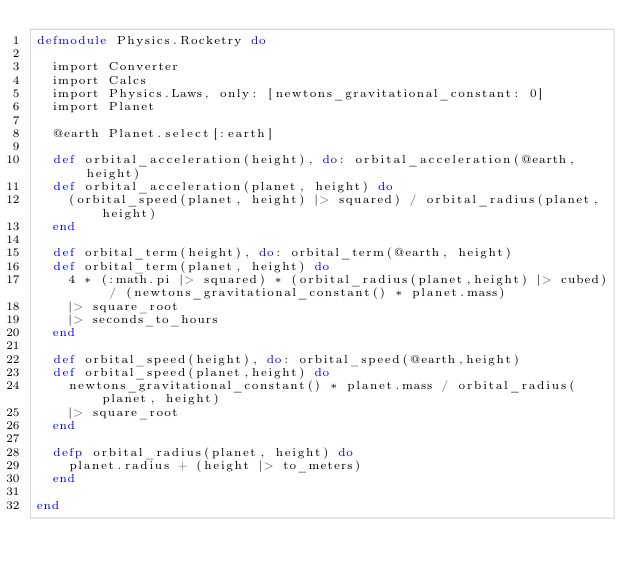Convert code to text. <code><loc_0><loc_0><loc_500><loc_500><_Elixir_>defmodule Physics.Rocketry do

	import Converter
	import Calcs
	import Physics.Laws, only: [newtons_gravitational_constant: 0]
	import Planet

	@earth Planet.select[:earth]

	def orbital_acceleration(height), do: orbital_acceleration(@earth,height)
	def orbital_acceleration(planet, height) do
		(orbital_speed(planet, height) |> squared) / orbital_radius(planet, height)
	end

	def orbital_term(height), do: orbital_term(@earth, height)
	def orbital_term(planet, height) do
		4 * (:math.pi |> squared) * (orbital_radius(planet,height) |> cubed) / (newtons_gravitational_constant() * planet.mass)
		|> square_root
		|> seconds_to_hours
	end

	def orbital_speed(height), do: orbital_speed(@earth,height)
	def orbital_speed(planet,height) do
		newtons_gravitational_constant() * planet.mass / orbital_radius(planet, height)
		|> square_root
	end

	defp orbital_radius(planet, height) do
		planet.radius + (height |> to_meters)
	end

end
</code> 